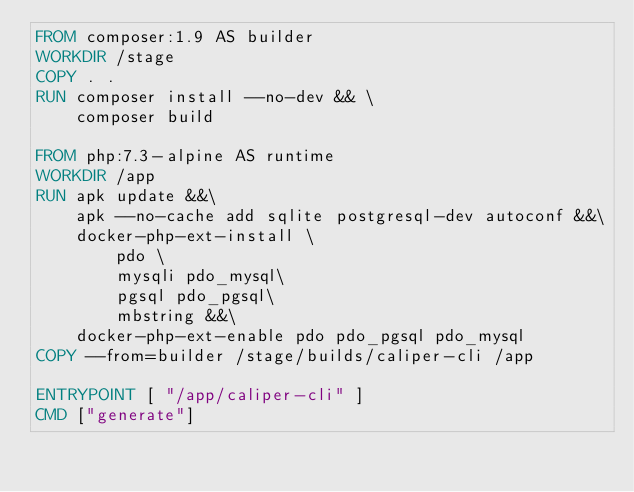Convert code to text. <code><loc_0><loc_0><loc_500><loc_500><_Dockerfile_>FROM composer:1.9 AS builder
WORKDIR /stage
COPY . .
RUN composer install --no-dev && \
    composer build

FROM php:7.3-alpine AS runtime
WORKDIR /app
RUN apk update &&\
    apk --no-cache add sqlite postgresql-dev autoconf &&\
    docker-php-ext-install \
        pdo \
        mysqli pdo_mysql\
        pgsql pdo_pgsql\
        mbstring &&\
    docker-php-ext-enable pdo pdo_pgsql pdo_mysql
COPY --from=builder /stage/builds/caliper-cli /app

ENTRYPOINT [ "/app/caliper-cli" ]
CMD ["generate"]</code> 